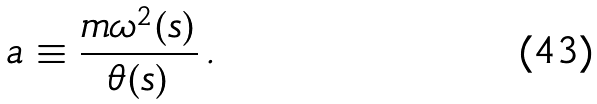<formula> <loc_0><loc_0><loc_500><loc_500>a \equiv \frac { m \omega ^ { 2 } ( s ) } { \theta ( s ) } \, .</formula> 